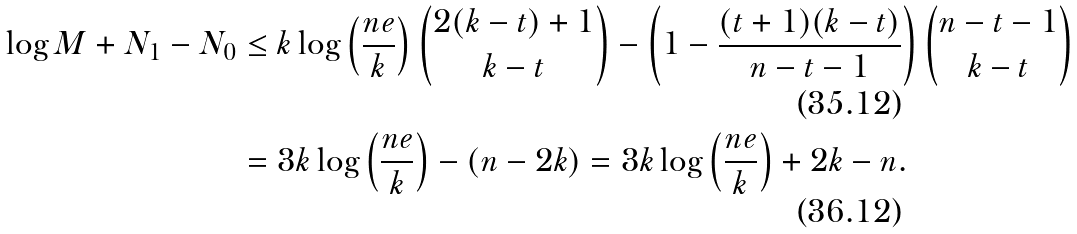<formula> <loc_0><loc_0><loc_500><loc_500>\log M + N _ { 1 } - N _ { 0 } & \leq k \log \left ( \frac { n e } { k } \right ) \binom { 2 ( k - t ) + 1 } { k - t } - \left ( 1 - \frac { ( t + 1 ) ( k - t ) } { n - t - 1 } \right ) \binom { n - t - 1 } { k - t } \\ & = 3 k \log \left ( \frac { n e } { k } \right ) - ( n - 2 k ) = 3 k \log \left ( \frac { n e } { k } \right ) + 2 k - n .</formula> 